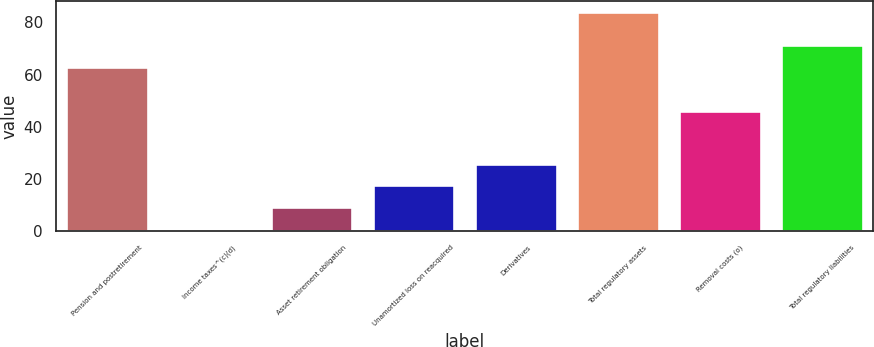Convert chart to OTSL. <chart><loc_0><loc_0><loc_500><loc_500><bar_chart><fcel>Pension and postretirement<fcel>Income taxes^(c)(d)<fcel>Asset retirement obligation<fcel>Unamortized loss on reacquired<fcel>Derivatives<fcel>Total regulatory assets<fcel>Removal costs (o)<fcel>Total regulatory liabilities<nl><fcel>63<fcel>1<fcel>9.3<fcel>17.6<fcel>25.9<fcel>84<fcel>46<fcel>71.3<nl></chart> 